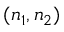Convert formula to latex. <formula><loc_0><loc_0><loc_500><loc_500>( n _ { 1 } , n _ { 2 } )</formula> 